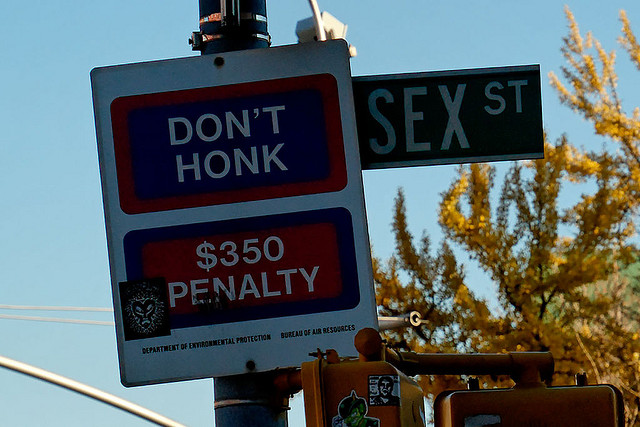<image>What building is at this address? It is unknown which building is at this address as it could be a hospital, business, shop or any other building. Which way is walnut st? It is unknown which way is Walnut St. There might be no sign for it. What building is at this address? I don't know what building is at this address. It could be any of the options mentioned. Which way is walnut st? I don't know which way is Walnut Street. It is not clear from the given information. 